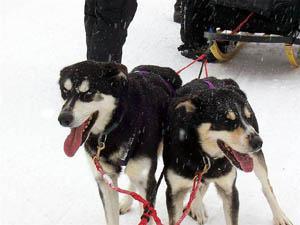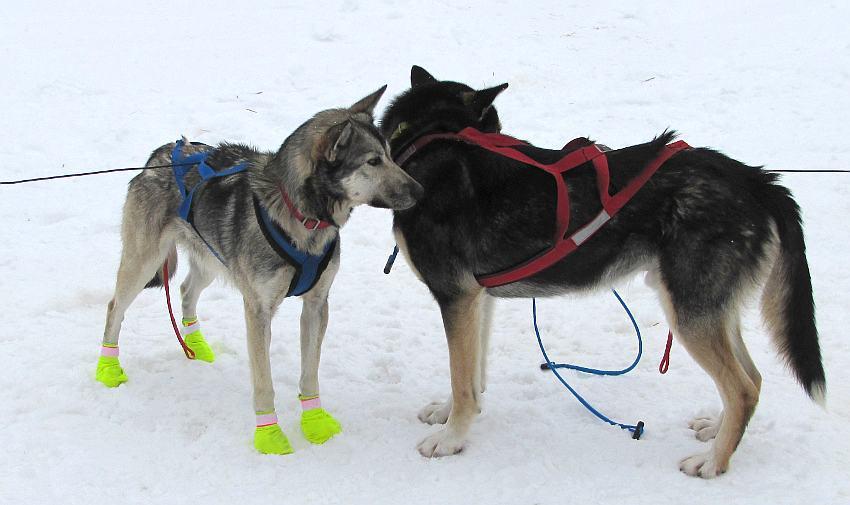The first image is the image on the left, the second image is the image on the right. Analyze the images presented: Is the assertion "Most of the dogs in one of the images are wearing boots." valid? Answer yes or no. No. The first image is the image on the left, the second image is the image on the right. Analyze the images presented: Is the assertion "Most of the dogs on one sled team are wearing black booties with a white band across the top." valid? Answer yes or no. No. 